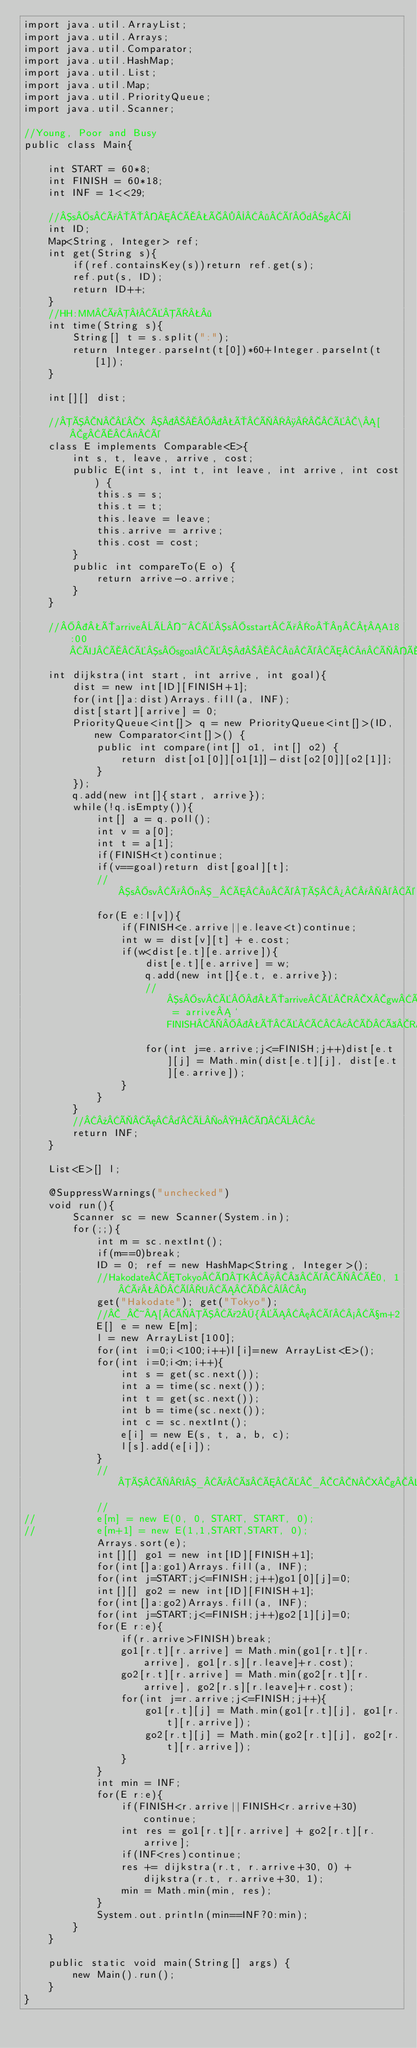<code> <loc_0><loc_0><loc_500><loc_500><_Java_>import java.util.ArrayList;
import java.util.Arrays;
import java.util.Comparator;
import java.util.HashMap;
import java.util.List;
import java.util.Map;
import java.util.PriorityQueue;
import java.util.Scanner;

//Young, Poor and Busy
public class Main{

	int START = 60*8;
	int FINISH = 60*18;
	int INF = 1<<29;
	
	//ssðÔÅÇ·édgÝ
	int ID;
	Map<String, Integer> ref;
	int get(String s){
		if(ref.containsKey(s))return ref.get(s);
		ref.put(s, ID);
		return ID++;
	}
	//HH:MMðªÉÏ·
	int time(String s){
		String[] t = s.split(":");
		return Integer.parseInt(t[0])*60+Integer.parseInt(t[1]);
	}
	
	int[][] dist;
	
	//ÓNX ÔÌ¸É\[gÅ«é
	class E implements Comparable<E>{
		int s, t, leave, arrive, cost;
		public E(int s, int t, int leave, int arrive, int cost) {
			this.s = s;
			this.t = t;
			this.leave = leave;
			this.arrive = arrive;
			this.cost = cost;
		}
		public int compareTo(E o) {
			return arrive-o.arrive;
		}
	}
	
	//ÔarriveÈ~Éssstartðo­µA18:00ÜÅÉssgoalÉ·éÆ«ÌÅ¬RXg
	int dijkstra(int start, int arrive, int goal){
		dist = new int[ID][FINISH+1];
		for(int[]a:dist)Arrays.fill(a, INF);
		dist[start][arrive] = 0;
		PriorityQueue<int[]> q = new PriorityQueue<int[]>(ID, new Comparator<int[]>() {
			public int compare(int[] o1, int[] o2) {
				return dist[o1[0]][o1[1]]-dist[o2[0]][o2[1]];
			}
		});
		q.add(new int[]{start, arrive});
		while(!q.isEmpty()){
			int[] a = q.poll();
			int v = a[0];
			int t = a[1];
			if(FINISH<t)continue;
			if(v==goal)return dist[goal][t];
			//ssvðn_Æ·éÓ¾¯©é
			for(E e:l[v]){
				if(FINISH<e.arrive||e.leave<t)continue;
				int w = dist[v][t] + e.cost;
				if(w<dist[e.t][e.arrive]){
					dist[e.t][e.arrive] = w;
					q.add(new int[]{e.t, e.arrive});
					//ssvÉÔarriveÉRXgwÅÅ«½ = arrive`FINISHÌÔÉÂ¢ÄàRXgwÅÅ«éÆ¢¤±Æ
					for(int j=e.arrive;j<=FINISH;j++)dist[e.t][j] = Math.min(dist[e.t][j], dist[e.t][e.arrive]);
				}
			}
		}
		//»Ìæ¤ÈoHÍÈ¢
		return INF;
	}
	
	List<E>[] l;
	
	@SuppressWarnings("unchecked")
	void run(){
		Scanner sc = new Scanner(System.in);
		for(;;){
			int m = sc.nextInt();
			if(m==0)break;
			ID = 0; ref = new HashMap<String, Integer>();
			//HakodateÆTokyoÍK¸ éÌÅ0, 1ðèUÁÄ¨­
			get("Hakodate"); get("Tokyo");
			//_~[ÌÓð2{Á¦é½ßm+2
			E[] e = new E[m];
			l = new ArrayList[100];
			for(int i=0;i<100;i++)l[i]=new ArrayList<E>();
			for(int i=0;i<m;i++){
				int s = get(sc.next());
				int a = time(sc.next());
				int t = get(sc.next());
				int b = time(sc.next());
				int c = sc.nextInt();
				e[i] = new E(s, t, a, b, c);
				l[s].add(e[i]);
			}
			//ÓÌI_ðàÆÉ_CNXgðç¹é
			//
//			e[m] = new E(0, 0, START, START, 0);
//			e[m+1] = new E(1,1,START,START, 0);
			Arrays.sort(e);
			int[][] go1 = new int[ID][FINISH+1];
			for(int[]a:go1)Arrays.fill(a, INF);
			for(int j=START;j<=FINISH;j++)go1[0][j]=0;
			int[][] go2 = new int[ID][FINISH+1];
			for(int[]a:go2)Arrays.fill(a, INF);
			for(int j=START;j<=FINISH;j++)go2[1][j]=0;
			for(E r:e){
				if(r.arrive>FINISH)break;
				go1[r.t][r.arrive] = Math.min(go1[r.t][r.arrive], go1[r.s][r.leave]+r.cost);
				go2[r.t][r.arrive] = Math.min(go2[r.t][r.arrive], go2[r.s][r.leave]+r.cost);
				for(int j=r.arrive;j<=FINISH;j++){
					go1[r.t][j] = Math.min(go1[r.t][j], go1[r.t][r.arrive]);
					go2[r.t][j] = Math.min(go2[r.t][j], go2[r.t][r.arrive]);
				}
			}
			int min = INF;
			for(E r:e){
				if(FINISH<r.arrive||FINISH<r.arrive+30)continue;
				int res = go1[r.t][r.arrive] + go2[r.t][r.arrive];
				if(INF<res)continue;
				res += dijkstra(r.t, r.arrive+30, 0) + dijkstra(r.t, r.arrive+30, 1);
				min = Math.min(min, res);
			}
			System.out.println(min==INF?0:min);
		}
	}
	
	public static void main(String[] args) {
		new Main().run();
	}
}</code> 